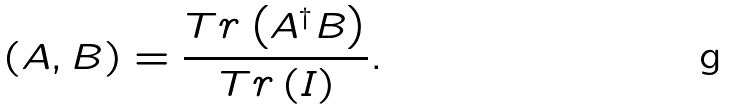<formula> <loc_0><loc_0><loc_500><loc_500>\left ( A , B \right ) = \frac { T r \left ( A ^ { \dag } B \right ) } { T r \left ( I \right ) } .</formula> 